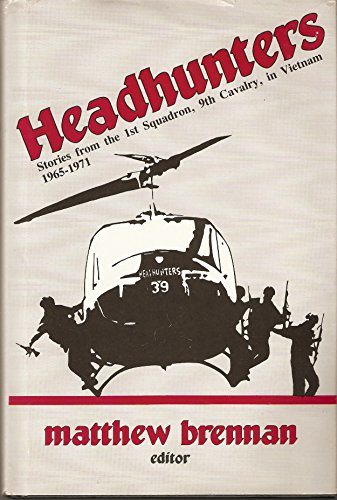How do the personal stories narrated in the book highlight the challenges faced by soldiers? The personal stories in the book delve deeply into the psychological and physical challenges faced by the soldiers of the 1st Squadron, 9th Cavalry. Through vivid narratives, the book paints a picture of the courage and hardships faced in combat, offering readers a raw, intimate glimpse into the day-to-day realities of war. 